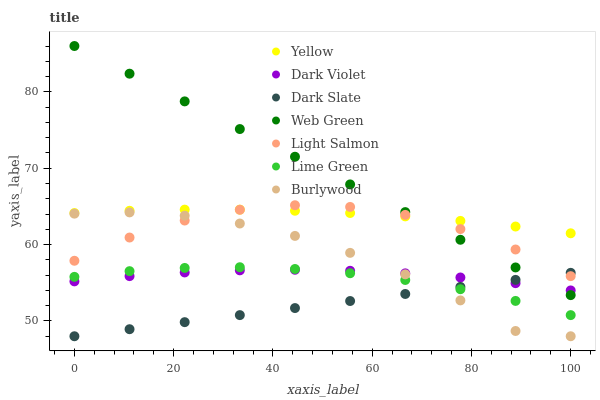Does Dark Slate have the minimum area under the curve?
Answer yes or no. Yes. Does Web Green have the maximum area under the curve?
Answer yes or no. Yes. Does Burlywood have the minimum area under the curve?
Answer yes or no. No. Does Burlywood have the maximum area under the curve?
Answer yes or no. No. Is Dark Slate the smoothest?
Answer yes or no. Yes. Is Burlywood the roughest?
Answer yes or no. Yes. Is Web Green the smoothest?
Answer yes or no. No. Is Web Green the roughest?
Answer yes or no. No. Does Burlywood have the lowest value?
Answer yes or no. Yes. Does Web Green have the lowest value?
Answer yes or no. No. Does Web Green have the highest value?
Answer yes or no. Yes. Does Burlywood have the highest value?
Answer yes or no. No. Is Dark Slate less than Yellow?
Answer yes or no. Yes. Is Light Salmon greater than Dark Violet?
Answer yes or no. Yes. Does Dark Slate intersect Dark Violet?
Answer yes or no. Yes. Is Dark Slate less than Dark Violet?
Answer yes or no. No. Is Dark Slate greater than Dark Violet?
Answer yes or no. No. Does Dark Slate intersect Yellow?
Answer yes or no. No. 